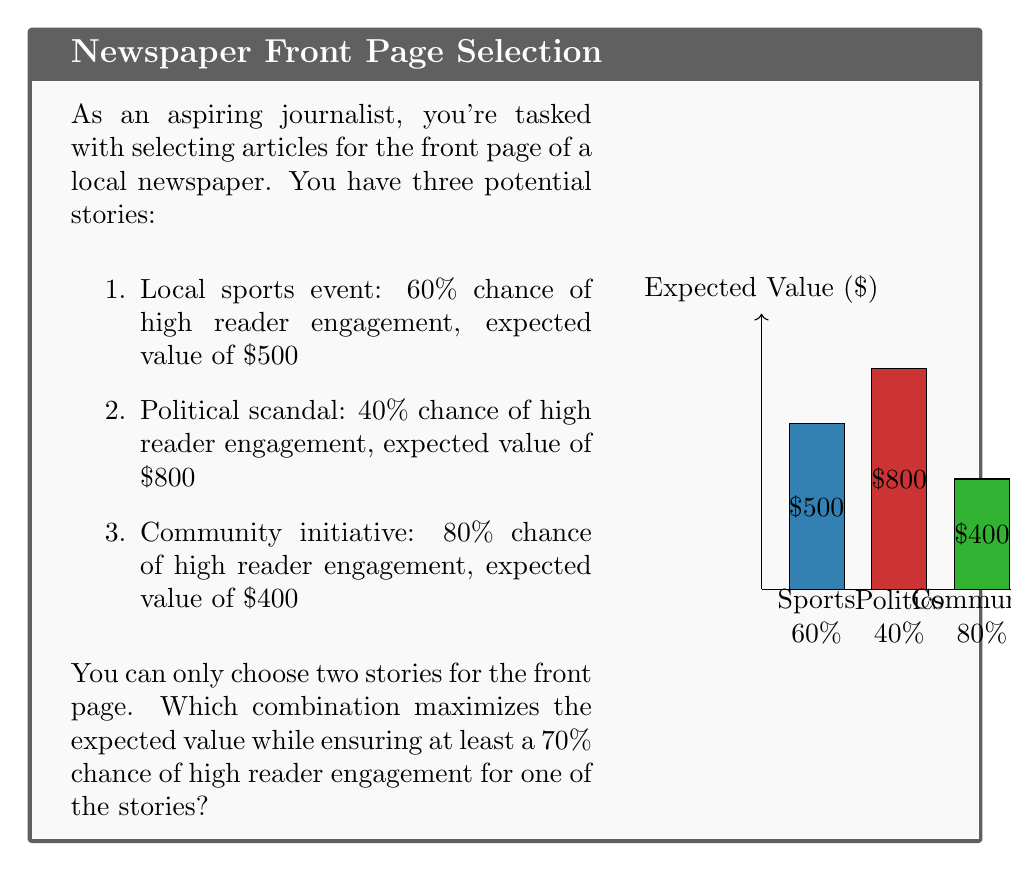Help me with this question. Let's approach this step-by-step:

1) First, we need to calculate the expected value (EV) for each combination:

   a) Sports + Politics: $EV = 500 + 800 = 1300$
   b) Sports + Community: $EV = 500 + 400 = 900$
   c) Politics + Community: $EV = 800 + 400 = 1200$

2) Now, we need to check which combinations meet the 70% engagement requirement:

   a) Sports + Politics: 
      $P(\text{at least one high engagement}) = 1 - P(\text{both low engagement})$
      $= 1 - (0.4 \times 0.6) = 1 - 0.24 = 0.76$ or 76%

   b) Sports + Community:
      $P(\text{at least one high engagement}) = 1 - P(\text{both low engagement})$
      $= 1 - (0.4 \times 0.2) = 1 - 0.08 = 0.92$ or 92%

   c) Politics + Community:
      $P(\text{at least one high engagement}) = 1 - P(\text{both low engagement})$
      $= 1 - (0.6 \times 0.2) = 1 - 0.12 = 0.88$ or 88%

3) All combinations meet the 70% engagement requirement.

4) Among these, the combination with the highest expected value is Sports + Politics, with an EV of $1300.

Therefore, the optimal choice is to select the Sports event and the Political scandal for the front page.
Answer: Sports event and Political scandal 